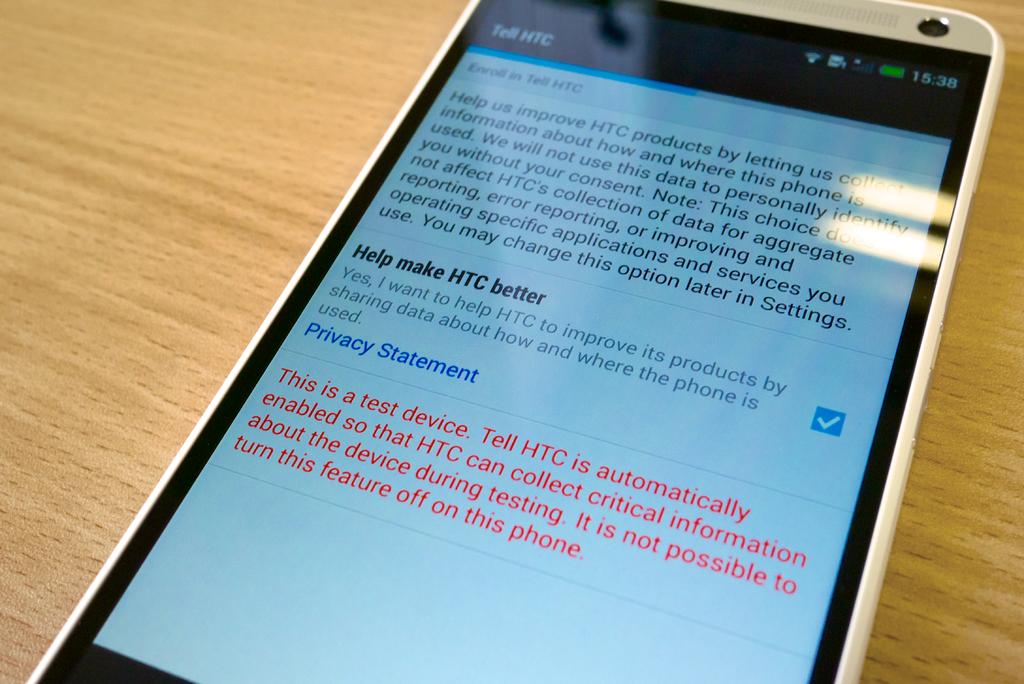What kind of phone is this?
Provide a succinct answer. Htc. 